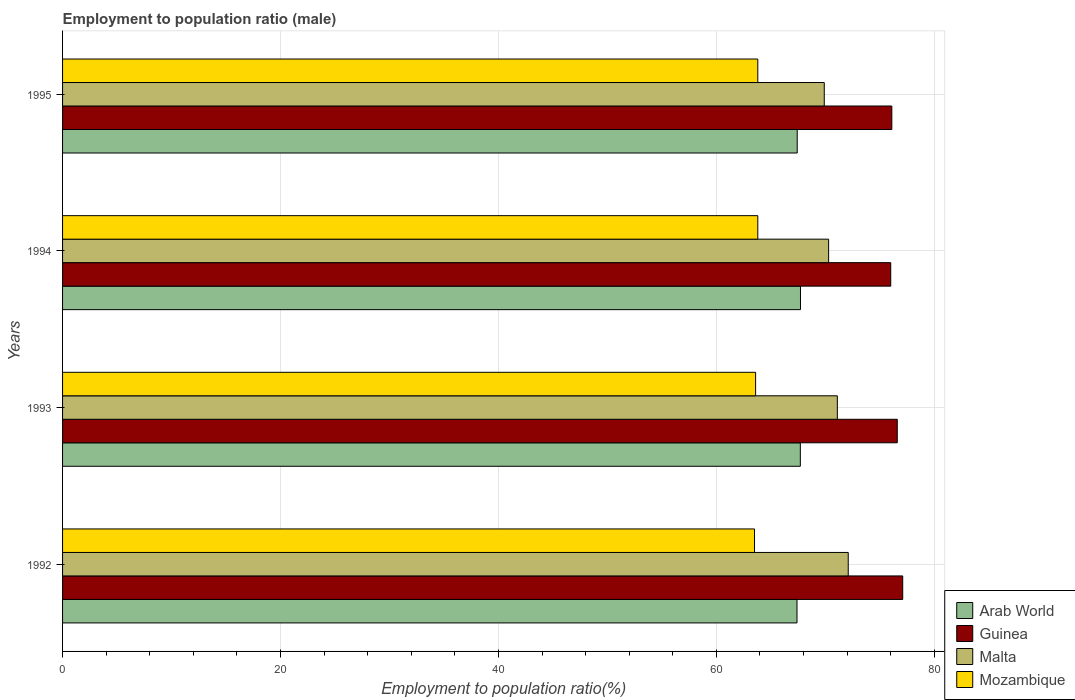How many different coloured bars are there?
Offer a terse response. 4. How many bars are there on the 4th tick from the top?
Give a very brief answer. 4. What is the label of the 2nd group of bars from the top?
Keep it short and to the point. 1994. What is the employment to population ratio in Guinea in 1992?
Your answer should be compact. 77.1. Across all years, what is the maximum employment to population ratio in Arab World?
Provide a short and direct response. 67.72. Across all years, what is the minimum employment to population ratio in Arab World?
Give a very brief answer. 67.4. What is the total employment to population ratio in Arab World in the graph?
Offer a terse response. 270.24. What is the difference between the employment to population ratio in Guinea in 1993 and that in 1995?
Your answer should be very brief. 0.5. What is the average employment to population ratio in Guinea per year?
Ensure brevity in your answer.  76.45. In the year 1994, what is the difference between the employment to population ratio in Arab World and employment to population ratio in Malta?
Your answer should be very brief. -2.58. What is the ratio of the employment to population ratio in Guinea in 1992 to that in 1993?
Offer a terse response. 1.01. Is the employment to population ratio in Malta in 1992 less than that in 1993?
Ensure brevity in your answer.  No. Is the difference between the employment to population ratio in Arab World in 1993 and 1994 greater than the difference between the employment to population ratio in Malta in 1993 and 1994?
Ensure brevity in your answer.  No. What is the difference between the highest and the second highest employment to population ratio in Mozambique?
Your answer should be very brief. 0. What is the difference between the highest and the lowest employment to population ratio in Arab World?
Keep it short and to the point. 0.32. Is the sum of the employment to population ratio in Mozambique in 1993 and 1995 greater than the maximum employment to population ratio in Arab World across all years?
Provide a short and direct response. Yes. What does the 4th bar from the top in 1992 represents?
Provide a succinct answer. Arab World. What does the 4th bar from the bottom in 1993 represents?
Give a very brief answer. Mozambique. Are the values on the major ticks of X-axis written in scientific E-notation?
Your answer should be very brief. No. Does the graph contain any zero values?
Make the answer very short. No. Does the graph contain grids?
Provide a succinct answer. Yes. How many legend labels are there?
Your answer should be compact. 4. What is the title of the graph?
Give a very brief answer. Employment to population ratio (male). What is the Employment to population ratio(%) of Arab World in 1992?
Offer a very short reply. 67.4. What is the Employment to population ratio(%) in Guinea in 1992?
Ensure brevity in your answer.  77.1. What is the Employment to population ratio(%) in Malta in 1992?
Provide a succinct answer. 72.1. What is the Employment to population ratio(%) of Mozambique in 1992?
Give a very brief answer. 63.5. What is the Employment to population ratio(%) in Arab World in 1993?
Offer a very short reply. 67.7. What is the Employment to population ratio(%) in Guinea in 1993?
Make the answer very short. 76.6. What is the Employment to population ratio(%) in Malta in 1993?
Provide a short and direct response. 71.1. What is the Employment to population ratio(%) of Mozambique in 1993?
Offer a terse response. 63.6. What is the Employment to population ratio(%) of Arab World in 1994?
Ensure brevity in your answer.  67.72. What is the Employment to population ratio(%) in Guinea in 1994?
Offer a very short reply. 76. What is the Employment to population ratio(%) of Malta in 1994?
Keep it short and to the point. 70.3. What is the Employment to population ratio(%) of Mozambique in 1994?
Make the answer very short. 63.8. What is the Employment to population ratio(%) of Arab World in 1995?
Provide a succinct answer. 67.42. What is the Employment to population ratio(%) of Guinea in 1995?
Offer a very short reply. 76.1. What is the Employment to population ratio(%) in Malta in 1995?
Give a very brief answer. 69.9. What is the Employment to population ratio(%) of Mozambique in 1995?
Provide a short and direct response. 63.8. Across all years, what is the maximum Employment to population ratio(%) of Arab World?
Keep it short and to the point. 67.72. Across all years, what is the maximum Employment to population ratio(%) of Guinea?
Your answer should be compact. 77.1. Across all years, what is the maximum Employment to population ratio(%) of Malta?
Ensure brevity in your answer.  72.1. Across all years, what is the maximum Employment to population ratio(%) of Mozambique?
Give a very brief answer. 63.8. Across all years, what is the minimum Employment to population ratio(%) in Arab World?
Ensure brevity in your answer.  67.4. Across all years, what is the minimum Employment to population ratio(%) of Malta?
Offer a very short reply. 69.9. Across all years, what is the minimum Employment to population ratio(%) in Mozambique?
Give a very brief answer. 63.5. What is the total Employment to population ratio(%) of Arab World in the graph?
Your answer should be compact. 270.24. What is the total Employment to population ratio(%) in Guinea in the graph?
Provide a succinct answer. 305.8. What is the total Employment to population ratio(%) in Malta in the graph?
Provide a short and direct response. 283.4. What is the total Employment to population ratio(%) of Mozambique in the graph?
Offer a very short reply. 254.7. What is the difference between the Employment to population ratio(%) in Arab World in 1992 and that in 1993?
Offer a very short reply. -0.31. What is the difference between the Employment to population ratio(%) of Malta in 1992 and that in 1993?
Your answer should be very brief. 1. What is the difference between the Employment to population ratio(%) in Arab World in 1992 and that in 1994?
Your answer should be very brief. -0.32. What is the difference between the Employment to population ratio(%) in Arab World in 1992 and that in 1995?
Your answer should be very brief. -0.02. What is the difference between the Employment to population ratio(%) of Guinea in 1992 and that in 1995?
Offer a terse response. 1. What is the difference between the Employment to population ratio(%) of Mozambique in 1992 and that in 1995?
Make the answer very short. -0.3. What is the difference between the Employment to population ratio(%) of Arab World in 1993 and that in 1994?
Offer a terse response. -0.01. What is the difference between the Employment to population ratio(%) of Malta in 1993 and that in 1994?
Your answer should be very brief. 0.8. What is the difference between the Employment to population ratio(%) of Arab World in 1993 and that in 1995?
Make the answer very short. 0.29. What is the difference between the Employment to population ratio(%) of Malta in 1993 and that in 1995?
Your response must be concise. 1.2. What is the difference between the Employment to population ratio(%) of Mozambique in 1993 and that in 1995?
Make the answer very short. -0.2. What is the difference between the Employment to population ratio(%) of Arab World in 1994 and that in 1995?
Ensure brevity in your answer.  0.3. What is the difference between the Employment to population ratio(%) in Mozambique in 1994 and that in 1995?
Ensure brevity in your answer.  0. What is the difference between the Employment to population ratio(%) in Arab World in 1992 and the Employment to population ratio(%) in Guinea in 1993?
Offer a very short reply. -9.2. What is the difference between the Employment to population ratio(%) in Arab World in 1992 and the Employment to population ratio(%) in Malta in 1993?
Ensure brevity in your answer.  -3.7. What is the difference between the Employment to population ratio(%) of Arab World in 1992 and the Employment to population ratio(%) of Mozambique in 1993?
Provide a succinct answer. 3.8. What is the difference between the Employment to population ratio(%) of Guinea in 1992 and the Employment to population ratio(%) of Malta in 1993?
Give a very brief answer. 6. What is the difference between the Employment to population ratio(%) in Malta in 1992 and the Employment to population ratio(%) in Mozambique in 1993?
Ensure brevity in your answer.  8.5. What is the difference between the Employment to population ratio(%) of Arab World in 1992 and the Employment to population ratio(%) of Guinea in 1994?
Offer a terse response. -8.6. What is the difference between the Employment to population ratio(%) of Arab World in 1992 and the Employment to population ratio(%) of Malta in 1994?
Provide a short and direct response. -2.9. What is the difference between the Employment to population ratio(%) in Arab World in 1992 and the Employment to population ratio(%) in Mozambique in 1994?
Your response must be concise. 3.6. What is the difference between the Employment to population ratio(%) of Guinea in 1992 and the Employment to population ratio(%) of Mozambique in 1994?
Provide a succinct answer. 13.3. What is the difference between the Employment to population ratio(%) in Malta in 1992 and the Employment to population ratio(%) in Mozambique in 1994?
Keep it short and to the point. 8.3. What is the difference between the Employment to population ratio(%) of Arab World in 1992 and the Employment to population ratio(%) of Guinea in 1995?
Make the answer very short. -8.7. What is the difference between the Employment to population ratio(%) of Arab World in 1992 and the Employment to population ratio(%) of Malta in 1995?
Your response must be concise. -2.5. What is the difference between the Employment to population ratio(%) in Arab World in 1992 and the Employment to population ratio(%) in Mozambique in 1995?
Make the answer very short. 3.6. What is the difference between the Employment to population ratio(%) in Guinea in 1992 and the Employment to population ratio(%) in Malta in 1995?
Offer a terse response. 7.2. What is the difference between the Employment to population ratio(%) in Malta in 1992 and the Employment to population ratio(%) in Mozambique in 1995?
Your response must be concise. 8.3. What is the difference between the Employment to population ratio(%) in Arab World in 1993 and the Employment to population ratio(%) in Guinea in 1994?
Your answer should be very brief. -8.3. What is the difference between the Employment to population ratio(%) in Arab World in 1993 and the Employment to population ratio(%) in Malta in 1994?
Keep it short and to the point. -2.6. What is the difference between the Employment to population ratio(%) in Arab World in 1993 and the Employment to population ratio(%) in Mozambique in 1994?
Your answer should be very brief. 3.9. What is the difference between the Employment to population ratio(%) in Guinea in 1993 and the Employment to population ratio(%) in Malta in 1994?
Your response must be concise. 6.3. What is the difference between the Employment to population ratio(%) in Malta in 1993 and the Employment to population ratio(%) in Mozambique in 1994?
Make the answer very short. 7.3. What is the difference between the Employment to population ratio(%) of Arab World in 1993 and the Employment to population ratio(%) of Guinea in 1995?
Ensure brevity in your answer.  -8.4. What is the difference between the Employment to population ratio(%) in Arab World in 1993 and the Employment to population ratio(%) in Malta in 1995?
Offer a very short reply. -2.2. What is the difference between the Employment to population ratio(%) in Arab World in 1993 and the Employment to population ratio(%) in Mozambique in 1995?
Offer a very short reply. 3.9. What is the difference between the Employment to population ratio(%) of Guinea in 1993 and the Employment to population ratio(%) of Malta in 1995?
Give a very brief answer. 6.7. What is the difference between the Employment to population ratio(%) of Malta in 1993 and the Employment to population ratio(%) of Mozambique in 1995?
Offer a very short reply. 7.3. What is the difference between the Employment to population ratio(%) in Arab World in 1994 and the Employment to population ratio(%) in Guinea in 1995?
Your answer should be compact. -8.38. What is the difference between the Employment to population ratio(%) of Arab World in 1994 and the Employment to population ratio(%) of Malta in 1995?
Provide a succinct answer. -2.18. What is the difference between the Employment to population ratio(%) in Arab World in 1994 and the Employment to population ratio(%) in Mozambique in 1995?
Ensure brevity in your answer.  3.92. What is the difference between the Employment to population ratio(%) of Guinea in 1994 and the Employment to population ratio(%) of Malta in 1995?
Ensure brevity in your answer.  6.1. What is the difference between the Employment to population ratio(%) of Guinea in 1994 and the Employment to population ratio(%) of Mozambique in 1995?
Your answer should be very brief. 12.2. What is the difference between the Employment to population ratio(%) of Malta in 1994 and the Employment to population ratio(%) of Mozambique in 1995?
Offer a terse response. 6.5. What is the average Employment to population ratio(%) in Arab World per year?
Make the answer very short. 67.56. What is the average Employment to population ratio(%) in Guinea per year?
Provide a succinct answer. 76.45. What is the average Employment to population ratio(%) in Malta per year?
Your answer should be compact. 70.85. What is the average Employment to population ratio(%) in Mozambique per year?
Ensure brevity in your answer.  63.67. In the year 1992, what is the difference between the Employment to population ratio(%) of Arab World and Employment to population ratio(%) of Guinea?
Your answer should be very brief. -9.7. In the year 1992, what is the difference between the Employment to population ratio(%) in Arab World and Employment to population ratio(%) in Malta?
Provide a succinct answer. -4.7. In the year 1992, what is the difference between the Employment to population ratio(%) of Arab World and Employment to population ratio(%) of Mozambique?
Offer a very short reply. 3.9. In the year 1992, what is the difference between the Employment to population ratio(%) of Guinea and Employment to population ratio(%) of Malta?
Offer a terse response. 5. In the year 1992, what is the difference between the Employment to population ratio(%) of Malta and Employment to population ratio(%) of Mozambique?
Your response must be concise. 8.6. In the year 1993, what is the difference between the Employment to population ratio(%) of Arab World and Employment to population ratio(%) of Guinea?
Your answer should be very brief. -8.9. In the year 1993, what is the difference between the Employment to population ratio(%) in Arab World and Employment to population ratio(%) in Malta?
Give a very brief answer. -3.4. In the year 1993, what is the difference between the Employment to population ratio(%) in Arab World and Employment to population ratio(%) in Mozambique?
Your answer should be compact. 4.1. In the year 1993, what is the difference between the Employment to population ratio(%) of Guinea and Employment to population ratio(%) of Malta?
Offer a very short reply. 5.5. In the year 1993, what is the difference between the Employment to population ratio(%) in Guinea and Employment to population ratio(%) in Mozambique?
Give a very brief answer. 13. In the year 1993, what is the difference between the Employment to population ratio(%) of Malta and Employment to population ratio(%) of Mozambique?
Your answer should be compact. 7.5. In the year 1994, what is the difference between the Employment to population ratio(%) in Arab World and Employment to population ratio(%) in Guinea?
Offer a very short reply. -8.28. In the year 1994, what is the difference between the Employment to population ratio(%) of Arab World and Employment to population ratio(%) of Malta?
Keep it short and to the point. -2.58. In the year 1994, what is the difference between the Employment to population ratio(%) of Arab World and Employment to population ratio(%) of Mozambique?
Provide a succinct answer. 3.92. In the year 1994, what is the difference between the Employment to population ratio(%) of Malta and Employment to population ratio(%) of Mozambique?
Your answer should be compact. 6.5. In the year 1995, what is the difference between the Employment to population ratio(%) in Arab World and Employment to population ratio(%) in Guinea?
Ensure brevity in your answer.  -8.68. In the year 1995, what is the difference between the Employment to population ratio(%) in Arab World and Employment to population ratio(%) in Malta?
Your response must be concise. -2.48. In the year 1995, what is the difference between the Employment to population ratio(%) of Arab World and Employment to population ratio(%) of Mozambique?
Provide a succinct answer. 3.62. In the year 1995, what is the difference between the Employment to population ratio(%) of Guinea and Employment to population ratio(%) of Mozambique?
Provide a short and direct response. 12.3. What is the ratio of the Employment to population ratio(%) in Malta in 1992 to that in 1993?
Your response must be concise. 1.01. What is the ratio of the Employment to population ratio(%) of Mozambique in 1992 to that in 1993?
Provide a succinct answer. 1. What is the ratio of the Employment to population ratio(%) in Arab World in 1992 to that in 1994?
Ensure brevity in your answer.  1. What is the ratio of the Employment to population ratio(%) in Guinea in 1992 to that in 1994?
Provide a short and direct response. 1.01. What is the ratio of the Employment to population ratio(%) of Malta in 1992 to that in 1994?
Offer a terse response. 1.03. What is the ratio of the Employment to population ratio(%) of Guinea in 1992 to that in 1995?
Provide a short and direct response. 1.01. What is the ratio of the Employment to population ratio(%) in Malta in 1992 to that in 1995?
Your answer should be compact. 1.03. What is the ratio of the Employment to population ratio(%) in Mozambique in 1992 to that in 1995?
Your answer should be compact. 1. What is the ratio of the Employment to population ratio(%) in Arab World in 1993 to that in 1994?
Provide a succinct answer. 1. What is the ratio of the Employment to population ratio(%) of Guinea in 1993 to that in 1994?
Ensure brevity in your answer.  1.01. What is the ratio of the Employment to population ratio(%) of Malta in 1993 to that in 1994?
Give a very brief answer. 1.01. What is the ratio of the Employment to population ratio(%) in Mozambique in 1993 to that in 1994?
Your answer should be compact. 1. What is the ratio of the Employment to population ratio(%) of Guinea in 1993 to that in 1995?
Give a very brief answer. 1.01. What is the ratio of the Employment to population ratio(%) in Malta in 1993 to that in 1995?
Provide a succinct answer. 1.02. What is the ratio of the Employment to population ratio(%) in Mozambique in 1993 to that in 1995?
Offer a very short reply. 1. What is the ratio of the Employment to population ratio(%) in Mozambique in 1994 to that in 1995?
Provide a short and direct response. 1. What is the difference between the highest and the second highest Employment to population ratio(%) of Arab World?
Provide a succinct answer. 0.01. What is the difference between the highest and the second highest Employment to population ratio(%) in Guinea?
Your answer should be compact. 0.5. What is the difference between the highest and the second highest Employment to population ratio(%) of Malta?
Offer a terse response. 1. What is the difference between the highest and the lowest Employment to population ratio(%) of Arab World?
Your answer should be very brief. 0.32. What is the difference between the highest and the lowest Employment to population ratio(%) of Guinea?
Make the answer very short. 1.1. What is the difference between the highest and the lowest Employment to population ratio(%) in Malta?
Provide a short and direct response. 2.2. 